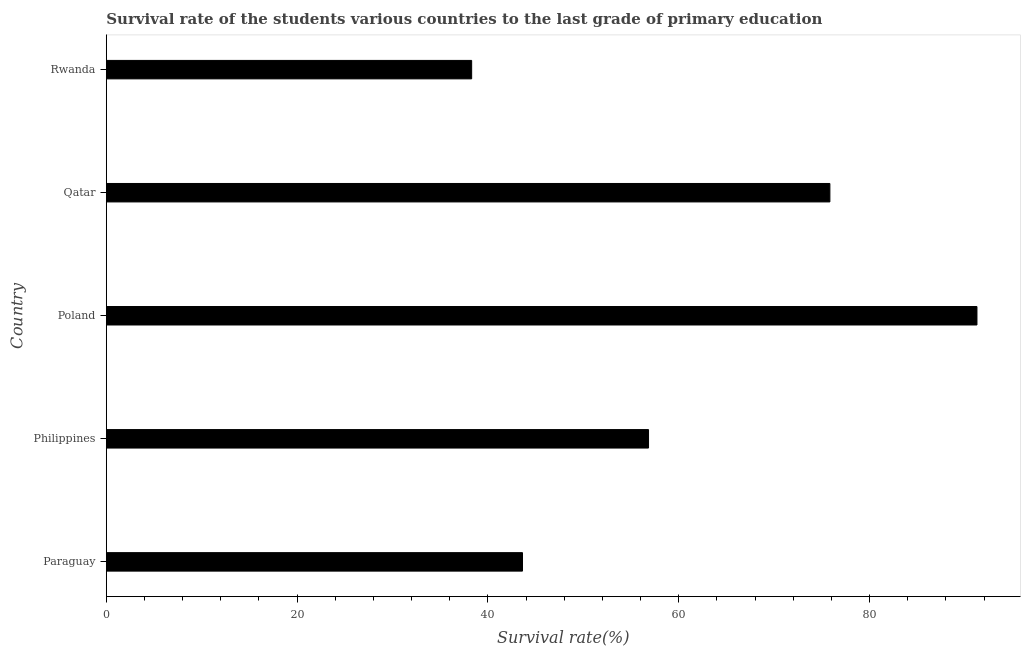Does the graph contain grids?
Make the answer very short. No. What is the title of the graph?
Offer a terse response. Survival rate of the students various countries to the last grade of primary education. What is the label or title of the X-axis?
Provide a succinct answer. Survival rate(%). What is the label or title of the Y-axis?
Provide a short and direct response. Country. What is the survival rate in primary education in Poland?
Offer a terse response. 91.25. Across all countries, what is the maximum survival rate in primary education?
Offer a very short reply. 91.25. Across all countries, what is the minimum survival rate in primary education?
Offer a terse response. 38.29. In which country was the survival rate in primary education maximum?
Offer a very short reply. Poland. In which country was the survival rate in primary education minimum?
Give a very brief answer. Rwanda. What is the sum of the survival rate in primary education?
Offer a very short reply. 305.83. What is the difference between the survival rate in primary education in Philippines and Qatar?
Your answer should be compact. -19.01. What is the average survival rate in primary education per country?
Ensure brevity in your answer.  61.17. What is the median survival rate in primary education?
Offer a terse response. 56.83. What is the ratio of the survival rate in primary education in Philippines to that in Rwanda?
Provide a succinct answer. 1.48. Is the difference between the survival rate in primary education in Paraguay and Qatar greater than the difference between any two countries?
Your response must be concise. No. What is the difference between the highest and the second highest survival rate in primary education?
Make the answer very short. 15.41. Is the sum of the survival rate in primary education in Philippines and Qatar greater than the maximum survival rate in primary education across all countries?
Offer a very short reply. Yes. What is the difference between the highest and the lowest survival rate in primary education?
Offer a terse response. 52.96. How many bars are there?
Ensure brevity in your answer.  5. Are all the bars in the graph horizontal?
Ensure brevity in your answer.  Yes. How many countries are there in the graph?
Give a very brief answer. 5. What is the difference between two consecutive major ticks on the X-axis?
Ensure brevity in your answer.  20. What is the Survival rate(%) of Paraguay?
Offer a terse response. 43.62. What is the Survival rate(%) of Philippines?
Your answer should be compact. 56.83. What is the Survival rate(%) of Poland?
Keep it short and to the point. 91.25. What is the Survival rate(%) of Qatar?
Make the answer very short. 75.84. What is the Survival rate(%) in Rwanda?
Give a very brief answer. 38.29. What is the difference between the Survival rate(%) in Paraguay and Philippines?
Provide a short and direct response. -13.21. What is the difference between the Survival rate(%) in Paraguay and Poland?
Make the answer very short. -47.63. What is the difference between the Survival rate(%) in Paraguay and Qatar?
Ensure brevity in your answer.  -32.22. What is the difference between the Survival rate(%) in Paraguay and Rwanda?
Ensure brevity in your answer.  5.33. What is the difference between the Survival rate(%) in Philippines and Poland?
Offer a terse response. -34.42. What is the difference between the Survival rate(%) in Philippines and Qatar?
Your answer should be very brief. -19.01. What is the difference between the Survival rate(%) in Philippines and Rwanda?
Your answer should be very brief. 18.54. What is the difference between the Survival rate(%) in Poland and Qatar?
Offer a very short reply. 15.41. What is the difference between the Survival rate(%) in Poland and Rwanda?
Provide a short and direct response. 52.96. What is the difference between the Survival rate(%) in Qatar and Rwanda?
Keep it short and to the point. 37.55. What is the ratio of the Survival rate(%) in Paraguay to that in Philippines?
Give a very brief answer. 0.77. What is the ratio of the Survival rate(%) in Paraguay to that in Poland?
Give a very brief answer. 0.48. What is the ratio of the Survival rate(%) in Paraguay to that in Qatar?
Keep it short and to the point. 0.57. What is the ratio of the Survival rate(%) in Paraguay to that in Rwanda?
Offer a very short reply. 1.14. What is the ratio of the Survival rate(%) in Philippines to that in Poland?
Give a very brief answer. 0.62. What is the ratio of the Survival rate(%) in Philippines to that in Qatar?
Keep it short and to the point. 0.75. What is the ratio of the Survival rate(%) in Philippines to that in Rwanda?
Your answer should be very brief. 1.48. What is the ratio of the Survival rate(%) in Poland to that in Qatar?
Ensure brevity in your answer.  1.2. What is the ratio of the Survival rate(%) in Poland to that in Rwanda?
Your response must be concise. 2.38. What is the ratio of the Survival rate(%) in Qatar to that in Rwanda?
Keep it short and to the point. 1.98. 